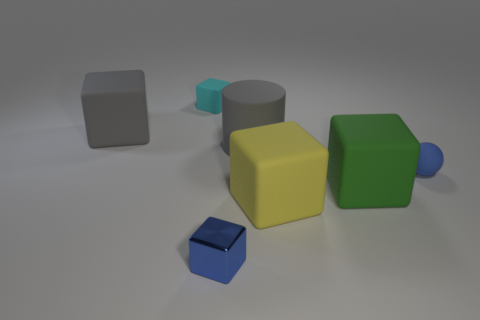Subtract all gray blocks. How many blocks are left? 4 Add 3 small yellow things. How many objects exist? 10 Subtract 1 cylinders. How many cylinders are left? 0 Subtract all green metal balls. Subtract all large cylinders. How many objects are left? 6 Add 2 matte balls. How many matte balls are left? 3 Add 6 tiny blue balls. How many tiny blue balls exist? 7 Subtract all gray blocks. How many blocks are left? 4 Subtract 1 yellow blocks. How many objects are left? 6 Subtract all cubes. How many objects are left? 2 Subtract all red cylinders. Subtract all yellow balls. How many cylinders are left? 1 